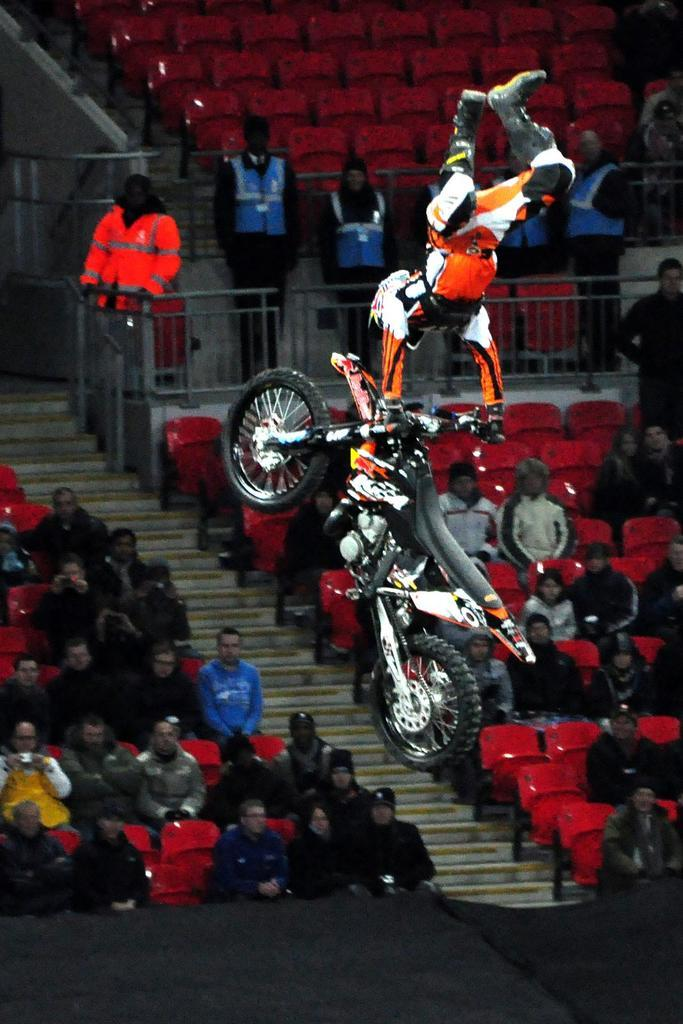What is the main activity happening in the image? There is a man performing a stunt with a motorbike in the image. Who is watching the motorbike stunt? There is an audience in the image, and they are watching the stunt. How are the audience members positioned in the image? The audience members are sitting on chairs. Are there any other people near the motorbike stunt? Yes, there are people standing near the motorbike stunt. What type of wrench is being used by the committee to fix the country in the image? There is no wrench, committee, or mention of fixing a country in the image. 